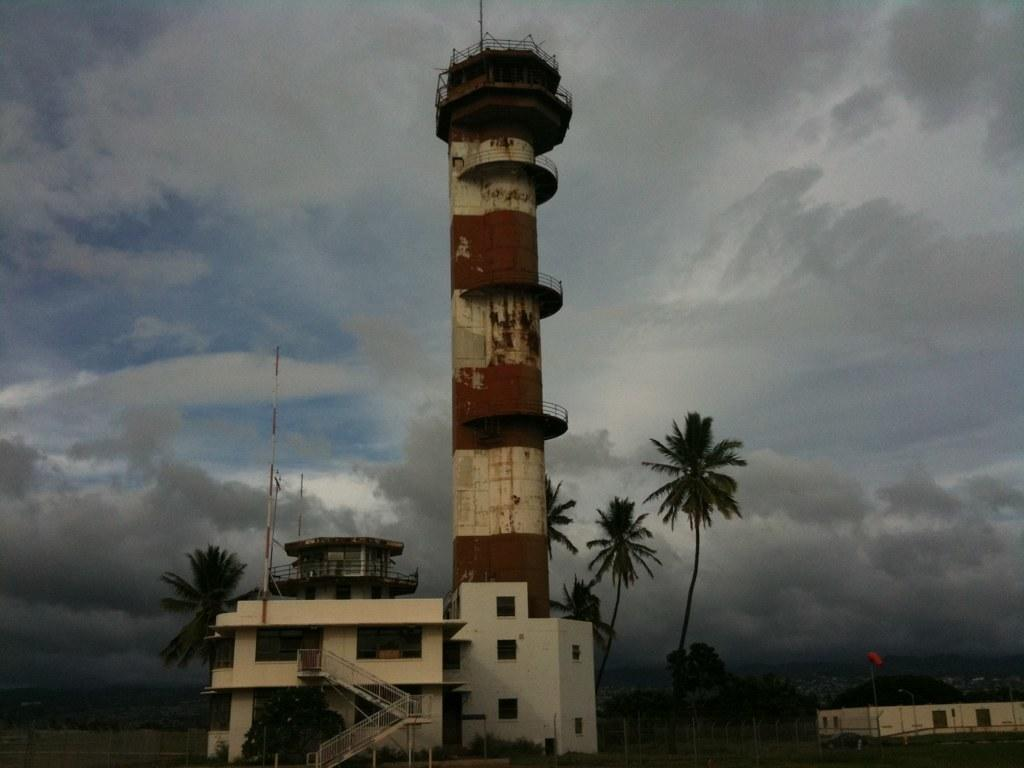What type of structures can be seen in the image? There are buildings and a tower in the image. What else is present in the image besides the structures? There are many trees in the image. What can be seen in the sky in the image? There are clouds in the sky in the image. What type of horn can be heard during the rainstorm in the image? There is no rainstorm or horn present in the image. 